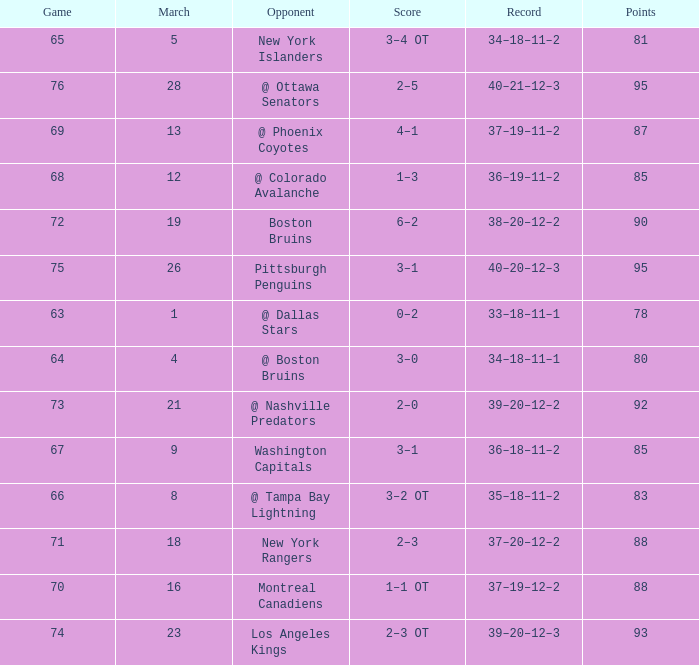Which Opponent has a Record of 38–20–12–2? Boston Bruins. 